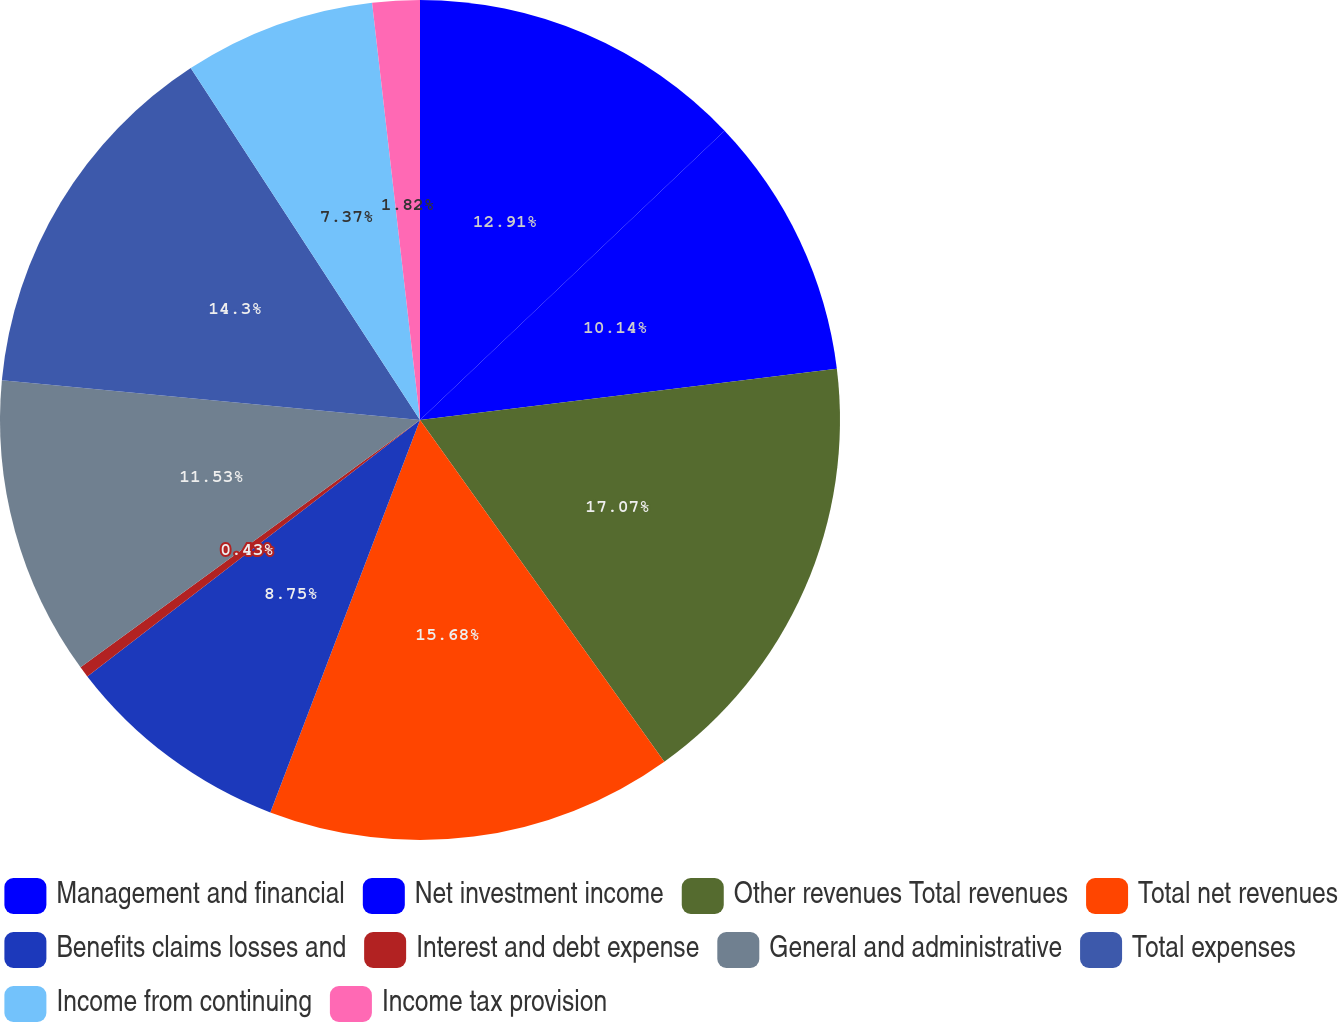Convert chart. <chart><loc_0><loc_0><loc_500><loc_500><pie_chart><fcel>Management and financial<fcel>Net investment income<fcel>Other revenues Total revenues<fcel>Total net revenues<fcel>Benefits claims losses and<fcel>Interest and debt expense<fcel>General and administrative<fcel>Total expenses<fcel>Income from continuing<fcel>Income tax provision<nl><fcel>12.91%<fcel>10.14%<fcel>17.07%<fcel>15.68%<fcel>8.75%<fcel>0.43%<fcel>11.53%<fcel>14.3%<fcel>7.37%<fcel>1.82%<nl></chart> 